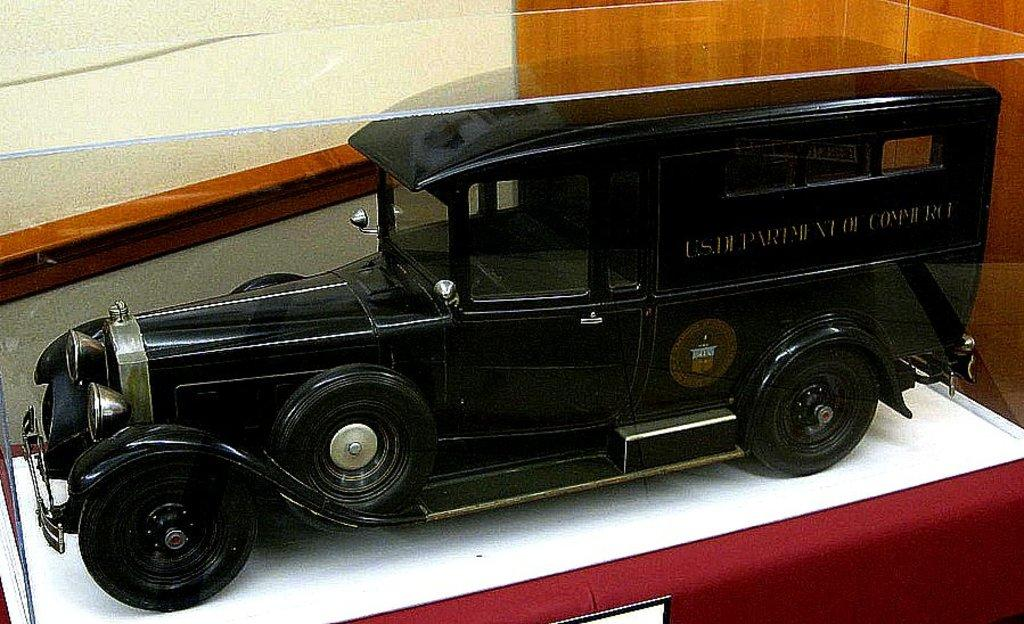What object is on the table in the image? There is a toy car on the table. What is written or printed on the toy car? There is text on the toy car. What can be seen behind the toy car? There is a wall behind the toy car. What type of wall is to the right of the toy car? There is a wooden wall to the right of the toy car. How many bees are sitting on the toy car in the image? There are no bees present in the image; it only features a toy car with text on it. What type of apples are being used to decorate the wooden wall in the image? There are no apples present in the image; the wooden wall is simply a part of the background. 